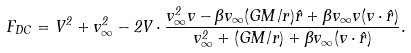Convert formula to latex. <formula><loc_0><loc_0><loc_500><loc_500>F _ { D C } = V ^ { 2 } + v _ { \infty } ^ { 2 } - 2 { V } \cdot \frac { v _ { \infty } ^ { 2 } { v } - \beta v _ { \infty } ( G M / r ) { \hat { r } } + \beta v _ { \infty } { v } ( { v } \cdot { \hat { r } } ) } { v _ { \infty } ^ { 2 } + ( G M / r ) + \beta v _ { \infty } ( { v } \cdot { \hat { r } } ) } .</formula> 